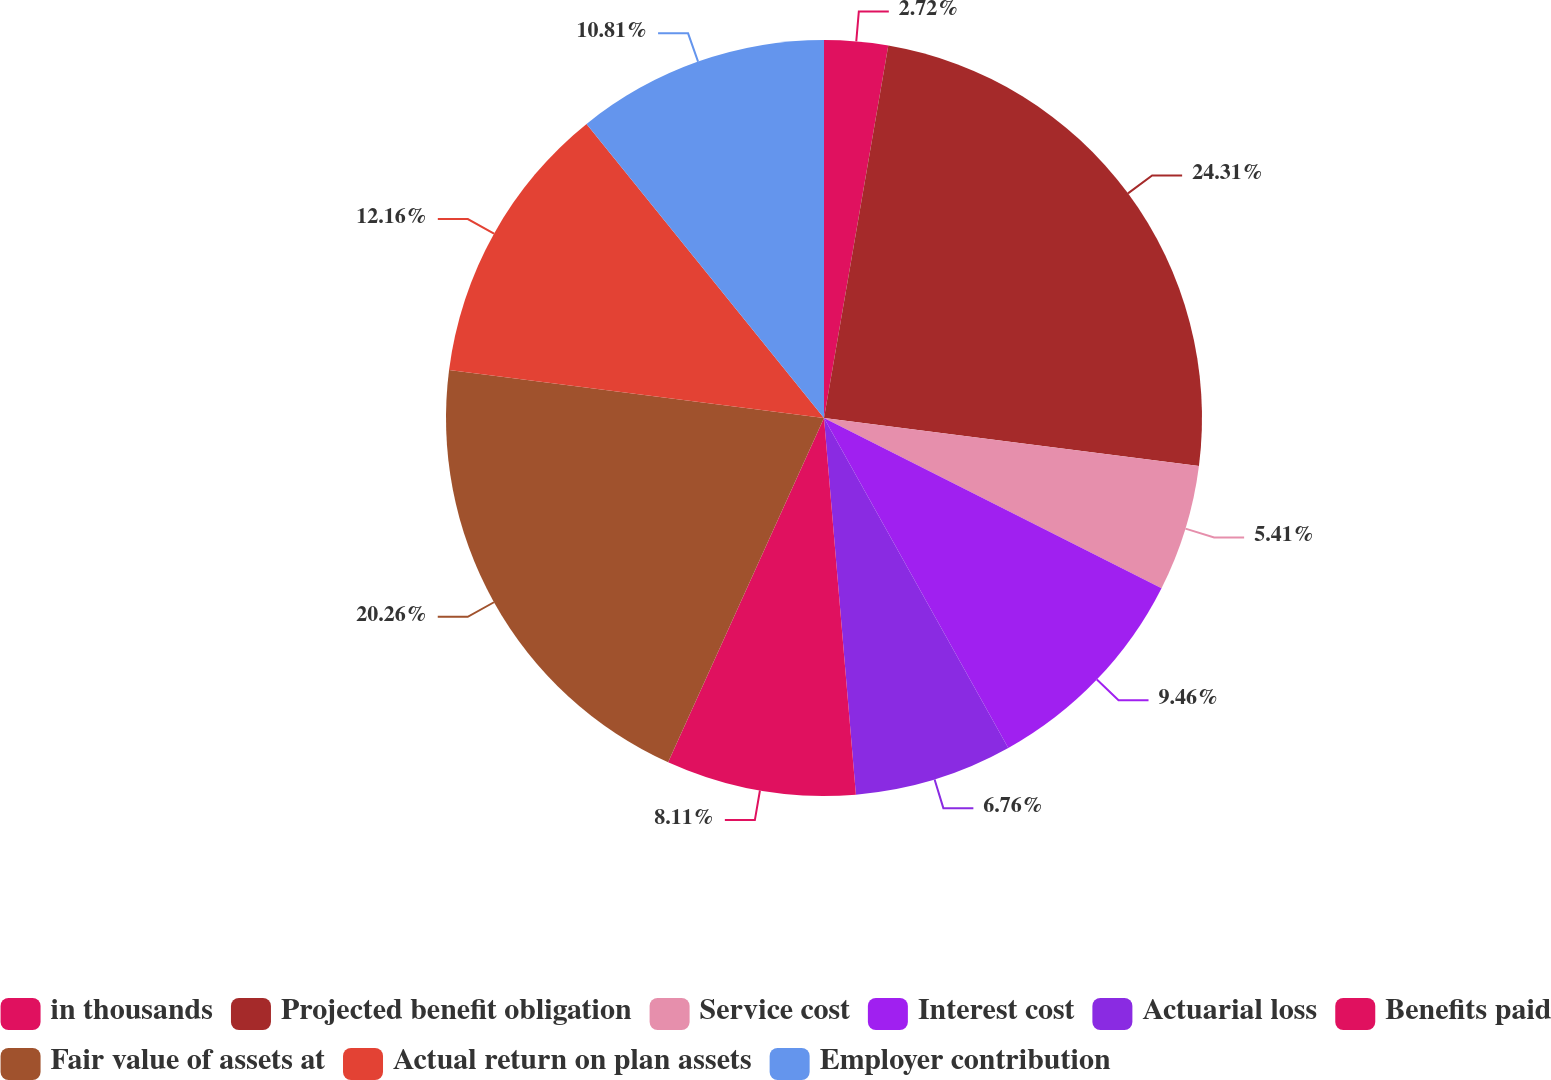Convert chart to OTSL. <chart><loc_0><loc_0><loc_500><loc_500><pie_chart><fcel>in thousands<fcel>Projected benefit obligation<fcel>Service cost<fcel>Interest cost<fcel>Actuarial loss<fcel>Benefits paid<fcel>Fair value of assets at<fcel>Actual return on plan assets<fcel>Employer contribution<nl><fcel>2.72%<fcel>24.3%<fcel>5.41%<fcel>9.46%<fcel>6.76%<fcel>8.11%<fcel>20.26%<fcel>12.16%<fcel>10.81%<nl></chart> 